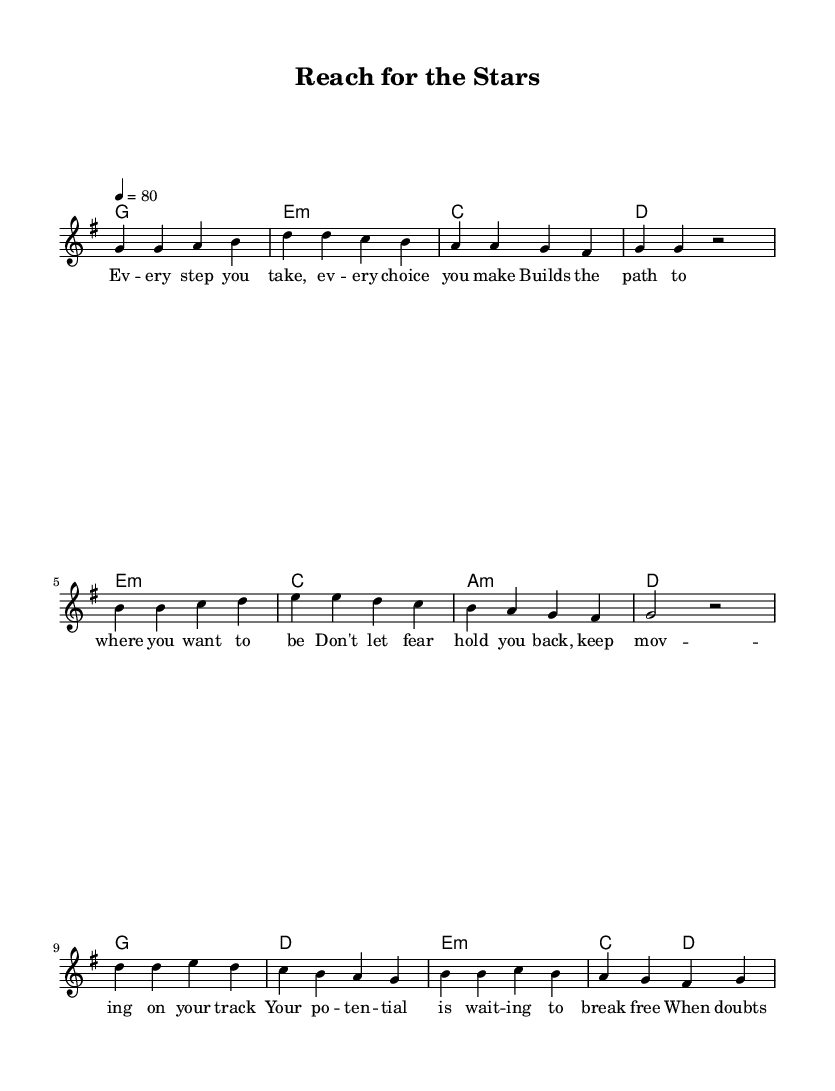What is the key signature of this music? The key signature is G major, which has one sharp (F#) indicated on the staff.
Answer: G major What is the time signature used in this piece? The time signature is 4/4, which is shown at the beginning of the score and indicates four beats per measure.
Answer: 4/4 What is the tempo marking for this piece? The tempo marking indicates a speed of 80 beats per minute, denoted by "4 = 80" at the start of the score.
Answer: 80 How many measures are there in the verse section? The verse section consists of four measures, as seen in the melody part labeled with the first four lines of lyrics.
Answer: 4 In the chorus, what is the melodic movement for the first two notes? The first two notes are a descending sequence from D to C, as understood from the melody written in the chorus section.
Answer: D to C What emotional theme does this song primarily convey? The lyrics and title suggest an inspirational theme about pursuing dreams and success, highlighted throughout the song's structure and text.
Answer: Inspirational What is the relationship between the verse and the chorus in terms of lyrical content? The verse introduces personal struggles, while the chorus offers a motivational message, creating a contrast between challenges and determination.
Answer: Contrast 